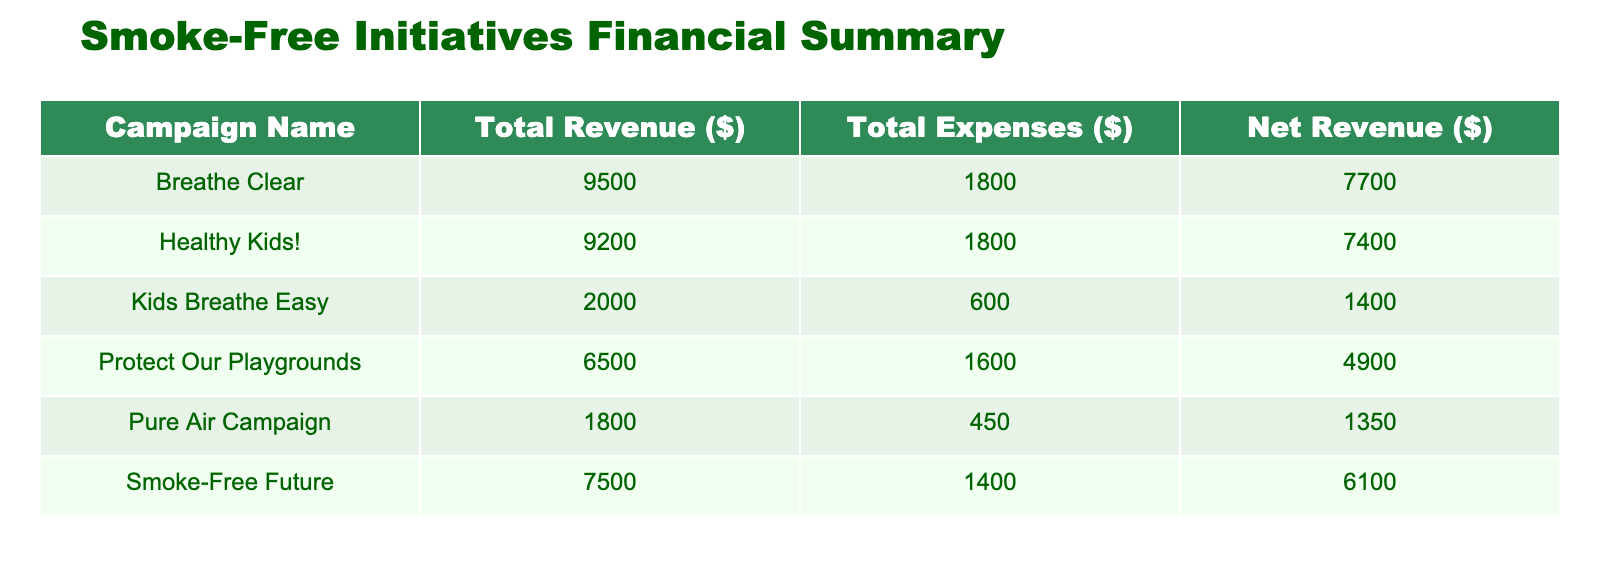What is the total revenue from the "Smoke-Free Future" campaign? The total revenue for the "Smoke-Free Future" campaign includes $3,500 from local business donations and $4,000 from the charity run. Adding these amounts gives us $3,500 + $4,000 = $7,500.
Answer: 7500 What is the total expense for the "Healthy Kids!" campaign? The total expense for the "Healthy Kids!" campaign includes $1,500 for consultant fees and $300 for travel expenses. Adding these amounts together gives $1,500 + $300 = $1,800.
Answer: 1800 Which campaign had the highest net revenue? To find the highest net revenue, we need to calculate the net revenue for each campaign: "Protect Our Playgrounds" has $1,100, "Healthy Kids!" has $6,500, "Kids Breathe Easy" has $1,400, "Smoke-Free Future" has $6,600, "Breathe Clear" has $5,700, and "Pure Air Campaign" has $1,350. The highest net revenue is $6,600 from the "Smoke-Free Future" campaign.
Answer: Smoke-Free Future Did "Pure Air Campaign" have a higher total revenue than "Kids Breathe Easy"? The "Pure Air Campaign" had a total revenue of $1,800, while "Kids Breathe Easy" had a total revenue of $2,000. Since $1,800 is less than $2,000, the statement is false.
Answer: No What is the total revenue generated through donations? To find the total revenue from donations, we consider "$1,500" from "Protect Our Playgrounds" and "$1,800" from "Pure Air Campaign". Adding these together gives $1,500 + $1,800 = $3,300.
Answer: 3300 What is the average expense per campaign? The total expenses amount to $5,850 (calculated by adding all expenses: $400 + $1,200 + $1,500 + $300 + $600 + $500 + $900 + $800 + $1,000 + $450 = $5,850). There are 6 campaigns. Thus, the average expense is $5,850 / 6 = $975.
Answer: 975 Which revenue source generated the least amount for its campaign? Looking at the revenue sources, "Community Bake Sale" generated the least, with $1,200. The other sources are higher: $1,500, $5,000, $8,000, $2,000, $3,500, $4,000, $2,500, and $7,000. Therefore, $1,200 from the Community Bake Sale is the least.
Answer: Community Bake Sale What is the combined total revenue from the campaigns that involved grants? The campaigns that involved grants are "Healthy Kids!" with $8,000 (government grant) and "Breathe Clear" with $7,000 (health organization grant). Adding these values gives $8,000 + $7,000 = $15,000 as the combined total revenue from grants.
Answer: 15000 